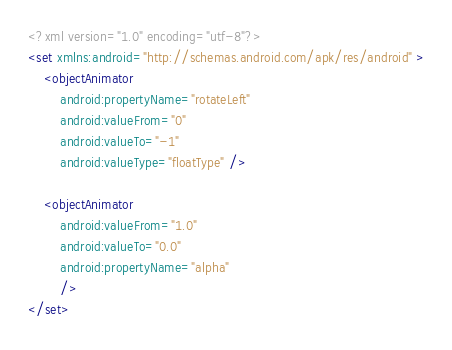Convert code to text. <code><loc_0><loc_0><loc_500><loc_500><_XML_><?xml version="1.0" encoding="utf-8"?>
<set xmlns:android="http://schemas.android.com/apk/res/android" >
    <objectAnimator
        android:propertyName="rotateLeft"
        android:valueFrom="0"
        android:valueTo="-1"
        android:valueType="floatType" />

    <objectAnimator
        android:valueFrom="1.0"
        android:valueTo="0.0"
        android:propertyName="alpha"
        />
</set></code> 